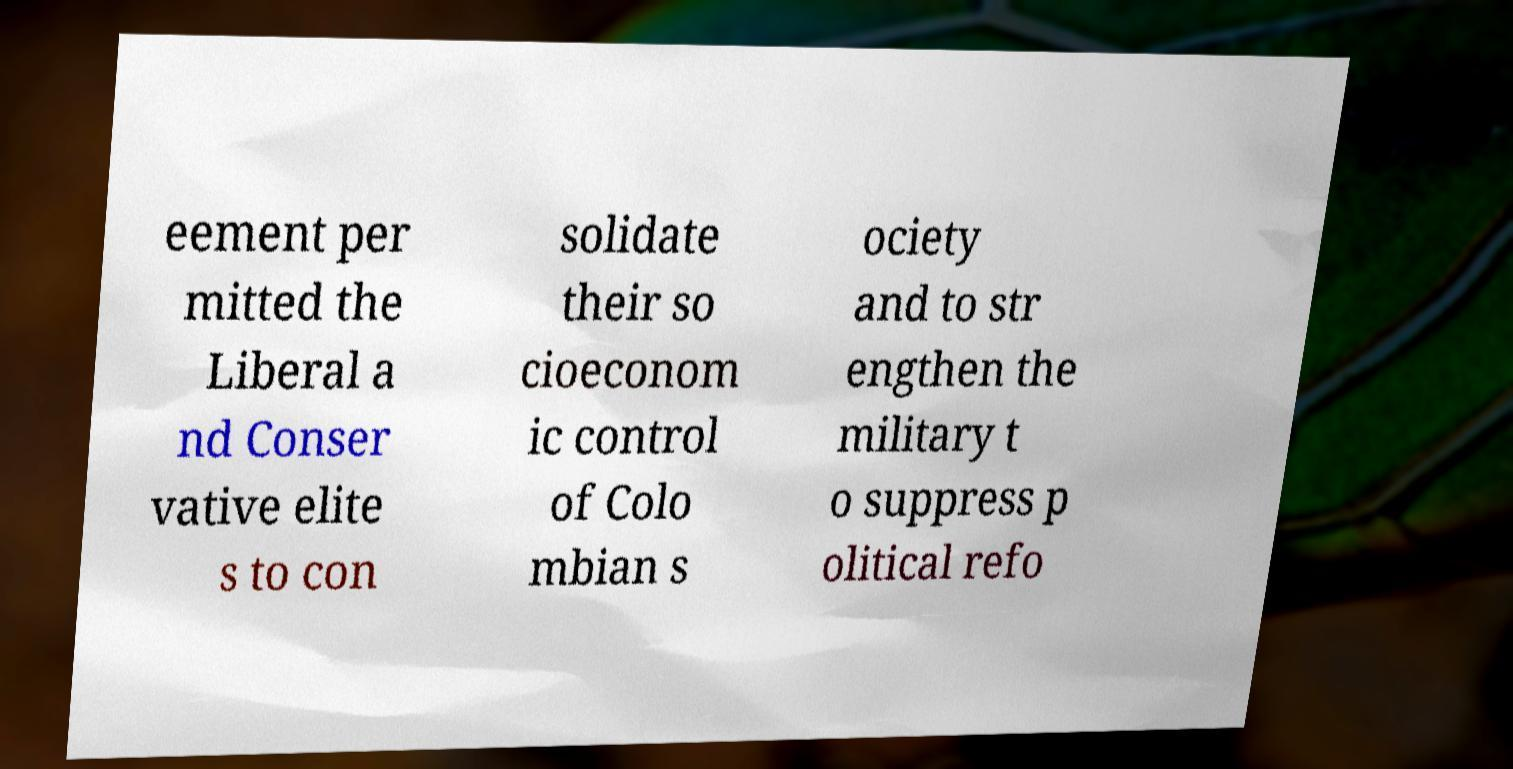I need the written content from this picture converted into text. Can you do that? eement per mitted the Liberal a nd Conser vative elite s to con solidate their so cioeconom ic control of Colo mbian s ociety and to str engthen the military t o suppress p olitical refo 